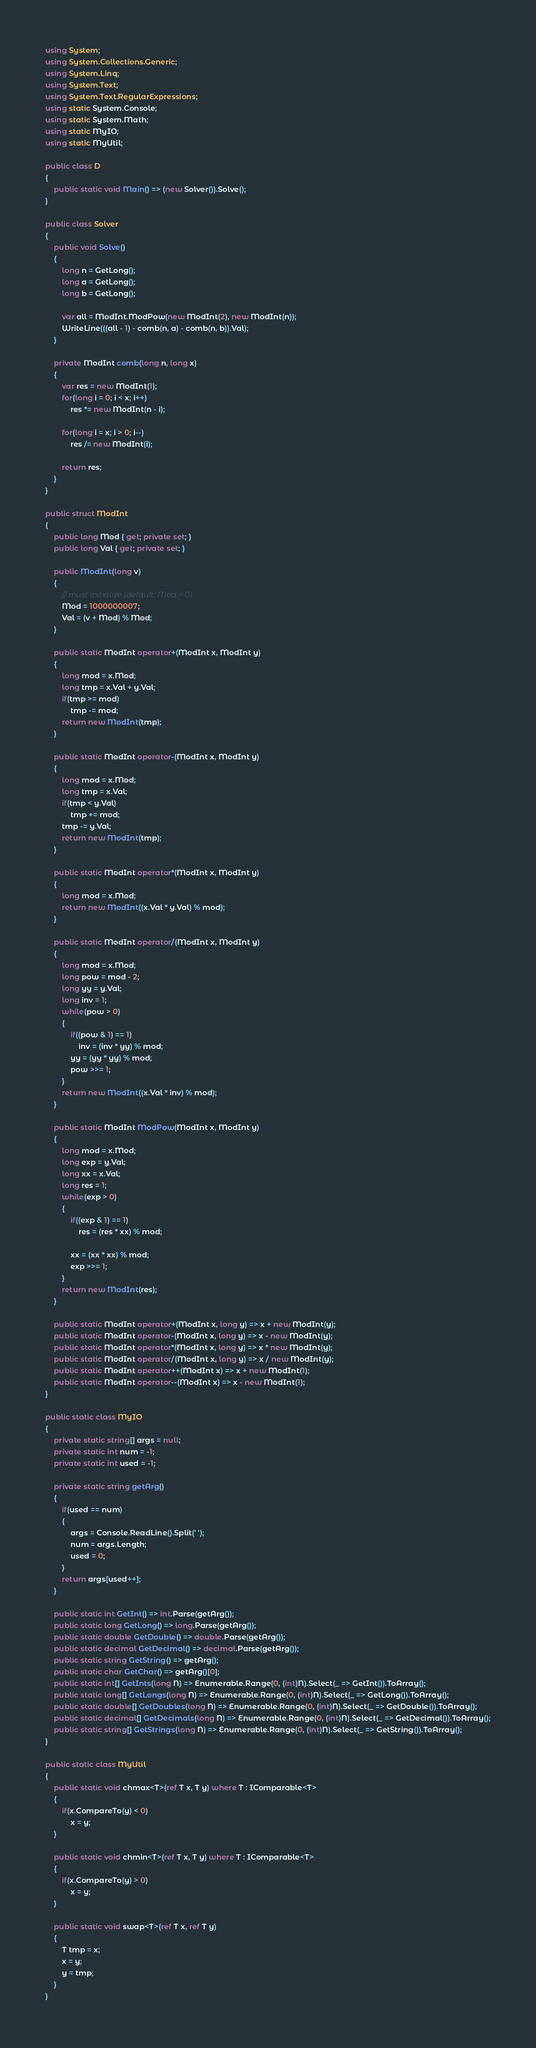<code> <loc_0><loc_0><loc_500><loc_500><_C#_>using System;
using System.Collections.Generic;
using System.Linq;
using System.Text;
using System.Text.RegularExpressions;
using static System.Console;
using static System.Math;
using static MyIO;
using static MyUtil;

public class D
{
	public static void Main() => (new Solver()).Solve();
}

public class Solver
{
	public void Solve()
	{
		long n = GetLong();
		long a = GetLong();
		long b = GetLong();

		var all = ModInt.ModPow(new ModInt(2), new ModInt(n));
		WriteLine(((all - 1) - comb(n, a) - comb(n, b)).Val);
	}

	private ModInt comb(long n, long x)
	{
		var res = new ModInt(1);
		for(long i = 0; i < x; i++)
			res *= new ModInt(n - i);

		for(long i = x; i > 0; i--)
			res /= new ModInt(i);

		return res;
	}
}

public struct ModInt
{
	public long Mod { get; private set; }
	public long Val { get; private set; }

	public ModInt(long v)
	{
		// must initialize (default: Mod = 0)
		Mod = 1000000007;
		Val = (v + Mod) % Mod;
	}

	public static ModInt operator+(ModInt x, ModInt y)
	{
		long mod = x.Mod;
		long tmp = x.Val + y.Val;
		if(tmp >= mod)
			tmp -= mod;
		return new ModInt(tmp);
	}

	public static ModInt operator-(ModInt x, ModInt y)
	{
		long mod = x.Mod;
		long tmp = x.Val;
		if(tmp < y.Val)
			tmp += mod;
		tmp -= y.Val;
		return new ModInt(tmp);
	}

	public static ModInt operator*(ModInt x, ModInt y)
	{
		long mod = x.Mod;
		return new ModInt((x.Val * y.Val) % mod);
	}

	public static ModInt operator/(ModInt x, ModInt y)
	{
		long mod = x.Mod;
		long pow = mod - 2;
		long yy = y.Val;
		long inv = 1;
		while(pow > 0)
		{
			if((pow & 1) == 1)
				inv = (inv * yy) % mod;
			yy = (yy * yy) % mod;
			pow >>= 1;
		}
		return new ModInt((x.Val * inv) % mod);
	}

	public static ModInt ModPow(ModInt x, ModInt y)
	{
		long mod = x.Mod;
		long exp = y.Val;
		long xx = x.Val;
		long res = 1;
		while(exp > 0)
		{
			if((exp & 1) == 1)
				res = (res * xx) % mod;

			xx = (xx * xx) % mod;
			exp >>= 1;
		}
		return new ModInt(res);
	}

	public static ModInt operator+(ModInt x, long y) => x + new ModInt(y);
	public static ModInt operator-(ModInt x, long y) => x - new ModInt(y);
	public static ModInt operator*(ModInt x, long y) => x * new ModInt(y);
	public static ModInt operator/(ModInt x, long y) => x / new ModInt(y);
	public static ModInt operator++(ModInt x) => x + new ModInt(1);
	public static ModInt operator--(ModInt x) => x - new ModInt(1);
}

public static class MyIO
{
	private static string[] args = null;
	private static int num = -1;
	private static int used = -1;

	private static string getArg()
	{
		if(used == num)
		{
			args = Console.ReadLine().Split(' ');
			num = args.Length;
			used = 0;
		}
		return args[used++];
	}

	public static int GetInt() => int.Parse(getArg());
	public static long GetLong() => long.Parse(getArg());
	public static double GetDouble() => double.Parse(getArg());
	public static decimal GetDecimal() => decimal.Parse(getArg());
	public static string GetString() => getArg();
	public static char GetChar() => getArg()[0];
	public static int[] GetInts(long N) => Enumerable.Range(0, (int)N).Select(_ => GetInt()).ToArray();
	public static long[] GetLongs(long N) => Enumerable.Range(0, (int)N).Select(_ => GetLong()).ToArray();
	public static double[] GetDoubles(long N) => Enumerable.Range(0, (int)N).Select(_ => GetDouble()).ToArray();
	public static decimal[] GetDecimals(long N) => Enumerable.Range(0, (int)N).Select(_ => GetDecimal()).ToArray();
	public static string[] GetStrings(long N) => Enumerable.Range(0, (int)N).Select(_ => GetString()).ToArray();
}

public static class MyUtil
{
	public static void chmax<T>(ref T x, T y) where T : IComparable<T>
	{
		if(x.CompareTo(y) < 0)
			x = y;
	}

	public static void chmin<T>(ref T x, T y) where T : IComparable<T>
	{
		if(x.CompareTo(y) > 0)
			x = y;
	}

	public static void swap<T>(ref T x, ref T y)
	{
		T tmp = x;
		x = y;
		y = tmp;
	}
}</code> 